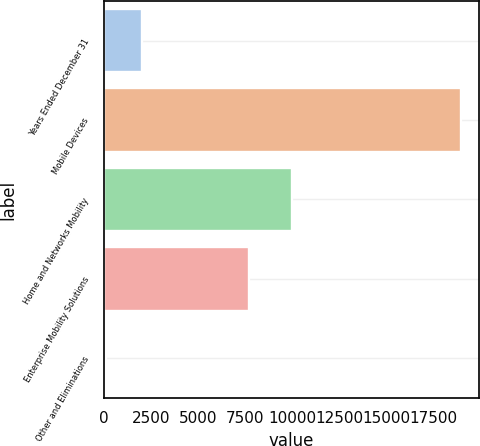Convert chart to OTSL. <chart><loc_0><loc_0><loc_500><loc_500><bar_chart><fcel>Years Ended December 31<fcel>Mobile Devices<fcel>Home and Networks Mobility<fcel>Enterprise Mobility Solutions<fcel>Other and Eliminations<nl><fcel>2007<fcel>18988<fcel>10014<fcel>7729<fcel>109<nl></chart> 